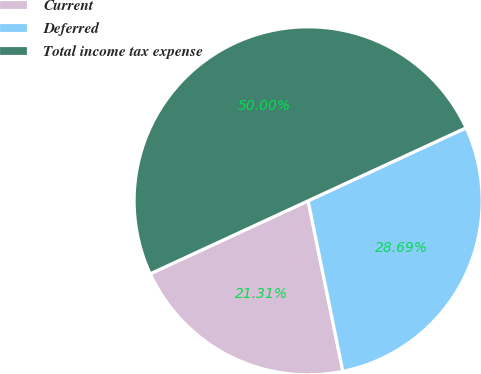Convert chart to OTSL. <chart><loc_0><loc_0><loc_500><loc_500><pie_chart><fcel>Current<fcel>Deferred<fcel>Total income tax expense<nl><fcel>21.31%<fcel>28.69%<fcel>50.0%<nl></chart> 